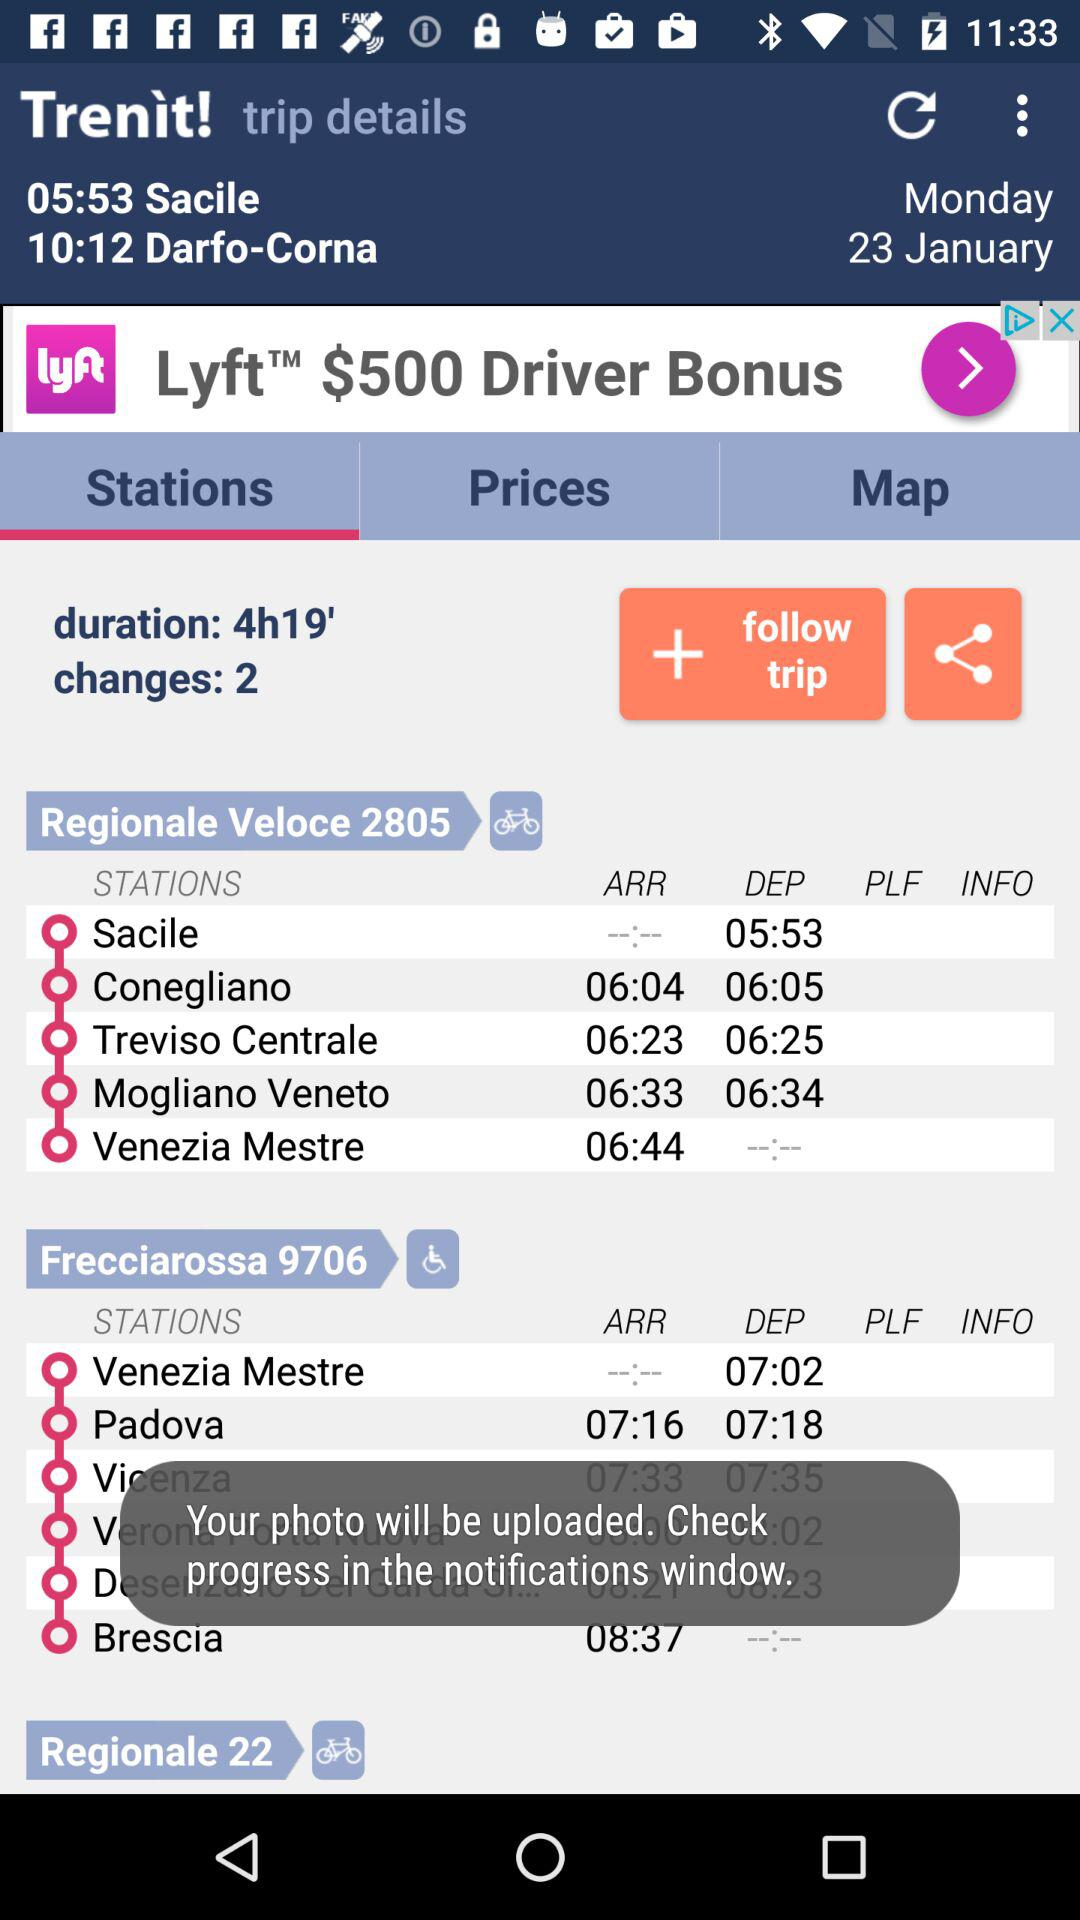What is the arrival time from Conegliano Station? The arrival time is 06:04. 